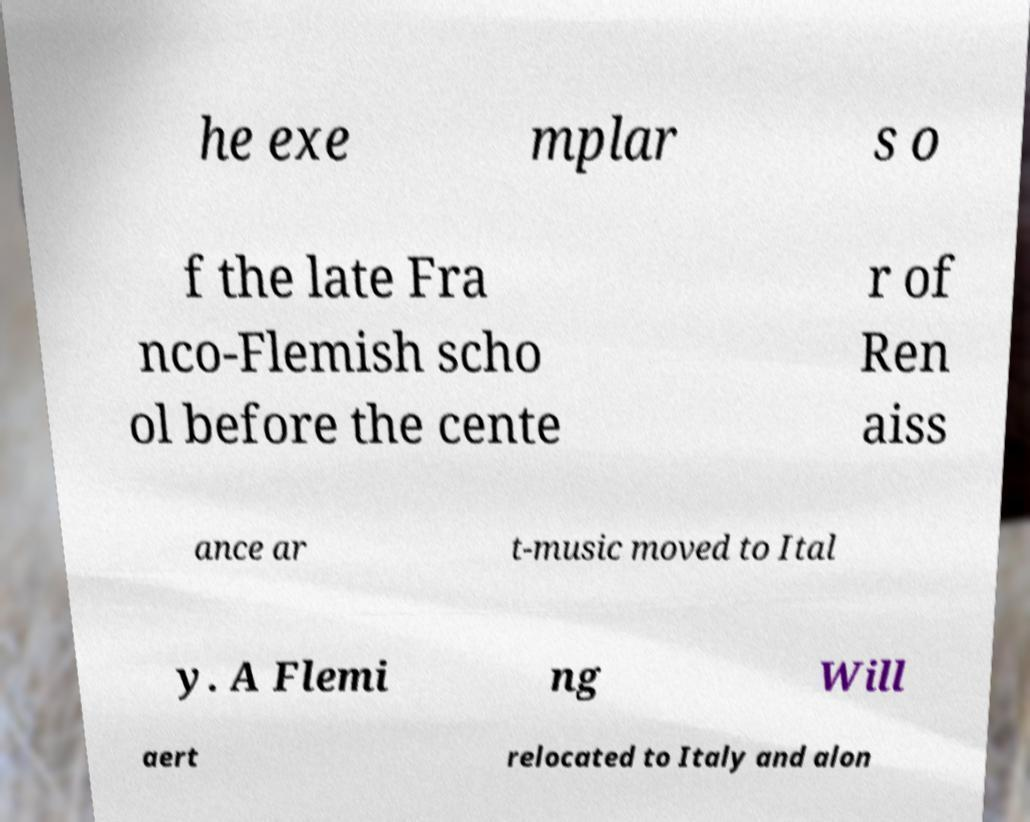I need the written content from this picture converted into text. Can you do that? he exe mplar s o f the late Fra nco-Flemish scho ol before the cente r of Ren aiss ance ar t-music moved to Ital y. A Flemi ng Will aert relocated to Italy and alon 